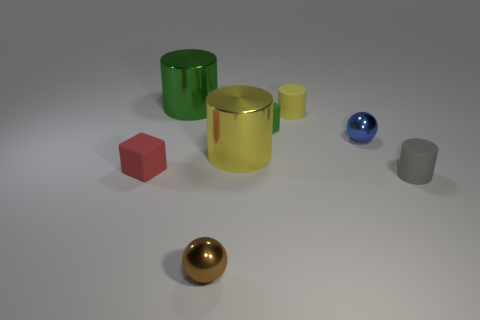How many cylinders are either yellow shiny things or gray matte things?
Keep it short and to the point. 2. Is the shape of the tiny brown shiny thing the same as the small metallic thing to the right of the tiny green block?
Make the answer very short. Yes. Are there fewer tiny blue shiny balls behind the big green thing than yellow rubber cylinders?
Offer a terse response. Yes. Are there any tiny gray cylinders right of the small blue object?
Make the answer very short. Yes. Is there a gray object that has the same shape as the yellow rubber thing?
Your answer should be compact. Yes. There is a green shiny thing that is the same size as the yellow metal cylinder; what shape is it?
Your response must be concise. Cylinder. How many objects are small metal spheres that are in front of the blue thing or small brown metal objects?
Keep it short and to the point. 1. There is a yellow cylinder in front of the tiny yellow thing; how big is it?
Provide a short and direct response. Large. Is there a cyan shiny object of the same size as the blue sphere?
Keep it short and to the point. No. There is a shiny cylinder in front of the green rubber block; is it the same size as the small gray matte thing?
Provide a short and direct response. No. 